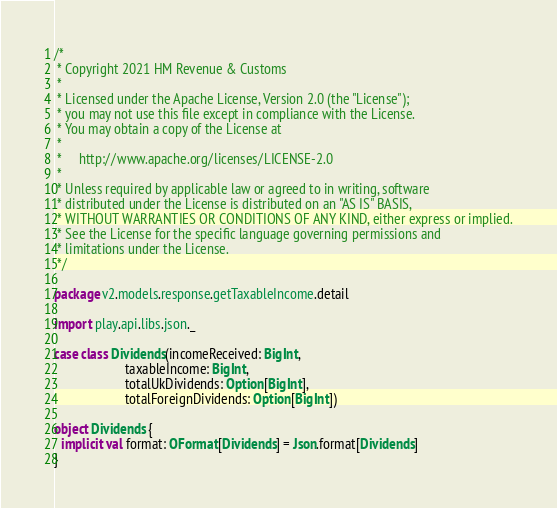<code> <loc_0><loc_0><loc_500><loc_500><_Scala_>/*
 * Copyright 2021 HM Revenue & Customs
 *
 * Licensed under the Apache License, Version 2.0 (the "License");
 * you may not use this file except in compliance with the License.
 * You may obtain a copy of the License at
 *
 *     http://www.apache.org/licenses/LICENSE-2.0
 *
 * Unless required by applicable law or agreed to in writing, software
 * distributed under the License is distributed on an "AS IS" BASIS,
 * WITHOUT WARRANTIES OR CONDITIONS OF ANY KIND, either express or implied.
 * See the License for the specific language governing permissions and
 * limitations under the License.
 */

package v2.models.response.getTaxableIncome.detail

import play.api.libs.json._

case class Dividends(incomeReceived: BigInt,
                     taxableIncome: BigInt,
                     totalUkDividends: Option[BigInt],
                     totalForeignDividends: Option[BigInt])

object Dividends {
  implicit val format: OFormat[Dividends] = Json.format[Dividends]
}</code> 